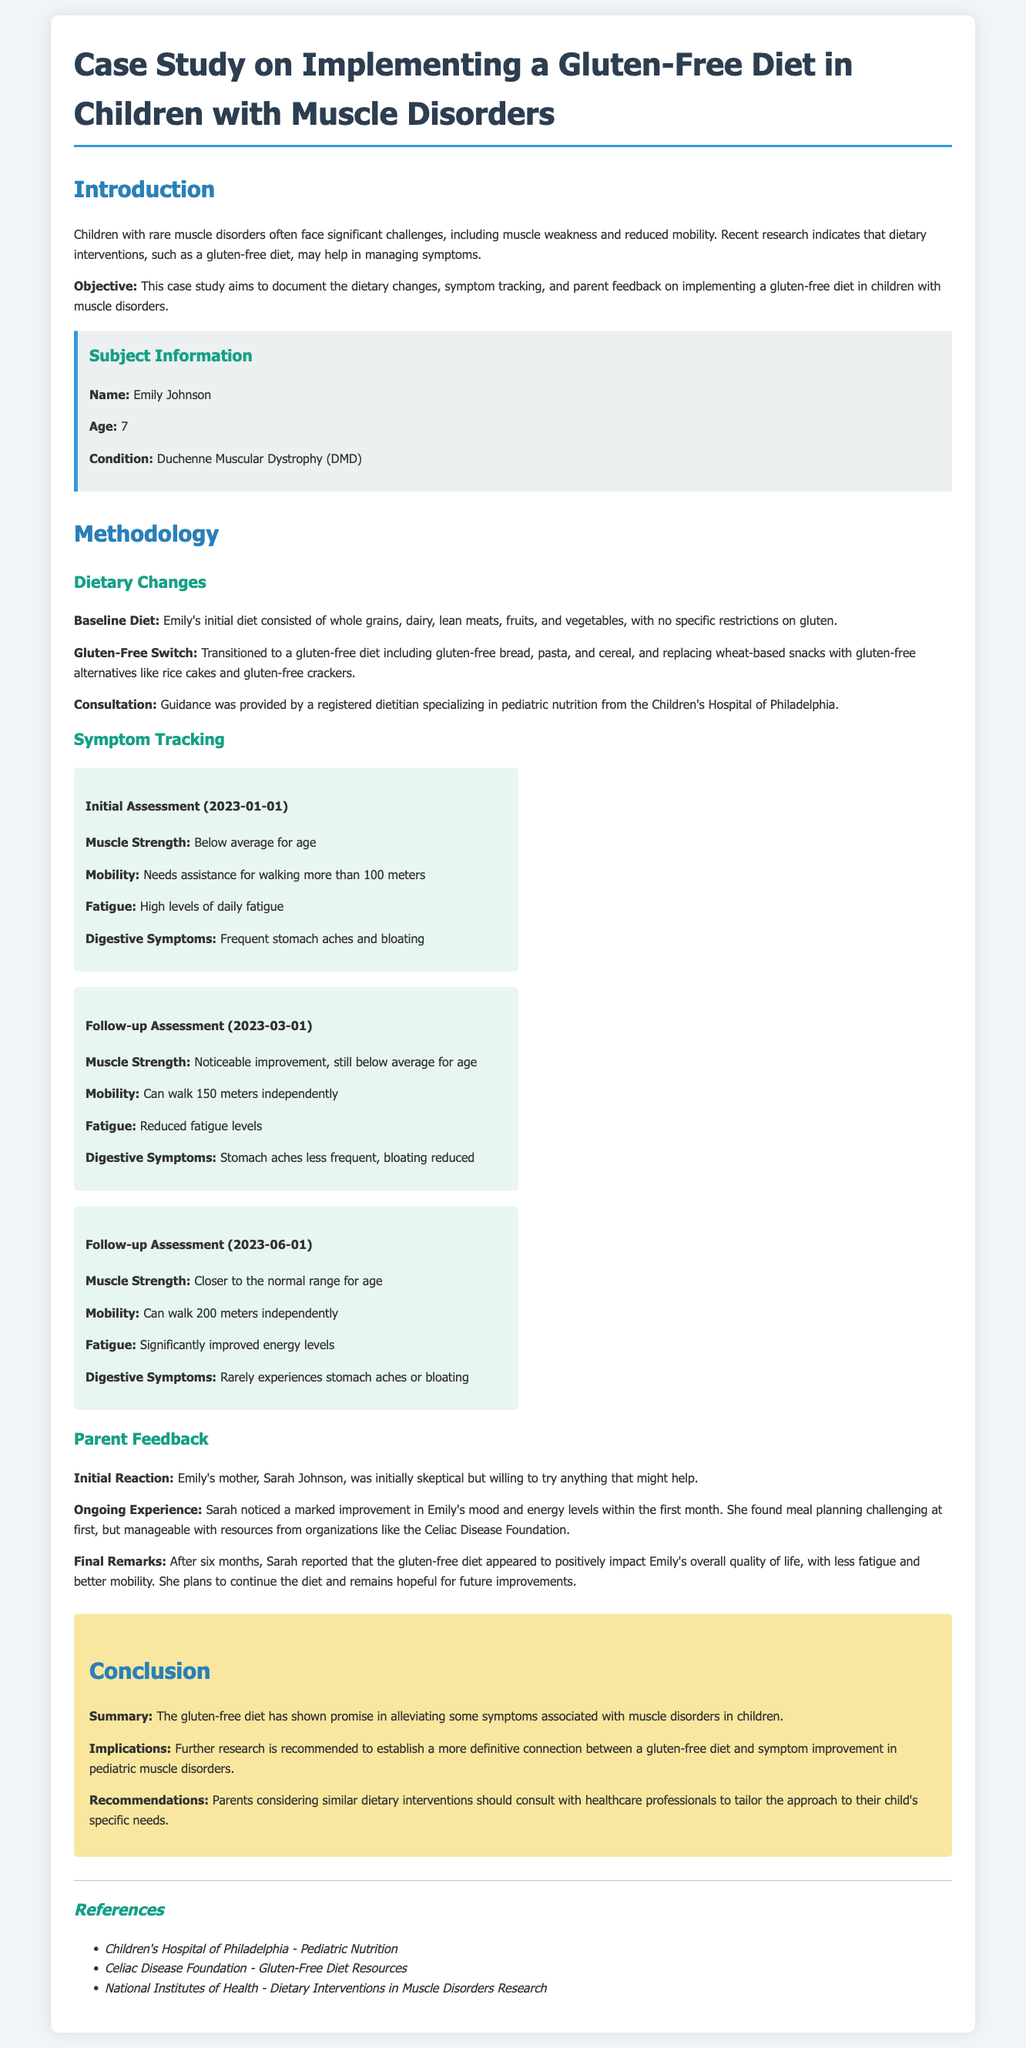What is the name of the subject in the case study? The name of the subject is provided in the Subject Information section.
Answer: Emily Johnson What is the age of the child in the case study? The child's age is mentioned in the Subject Information section.
Answer: 7 What condition is Emily diagnosed with? The diagnosed condition is listed in the Subject Information section.
Answer: Duchenne Muscular Dystrophy (DMD) When was the initial assessment conducted? The date of the initial assessment is stated in the Symptom Tracking section under Initial Assessment.
Answer: 2023-01-01 How did Emily's muscle strength change by the follow-up assessment in June 2023? The document provides comparisons of muscle strength across assessments, specifically in the Follow-up Assessment section.
Answer: Closer to the normal range for age What gluten-free alternatives were mentioned for snacks? The types of gluten-free alternatives are outlined in the Dietary Changes section.
Answer: Rice cakes and gluten-free crackers What was the initial reaction of Emily's mother to the gluten-free diet? Details about the mother's reaction can be found in the Parent Feedback section.
Answer: Initially skeptical Was there a noted improvement in Emily's mood after dietary changes? The Parent Feedback section discusses changes in Emily's mood following the diet.
Answer: Yes What is recommended for parents considering a gluten-free diet for their child? The Recommendations section includes advice for parents about dietary interventions.
Answer: Consult with healthcare professionals 